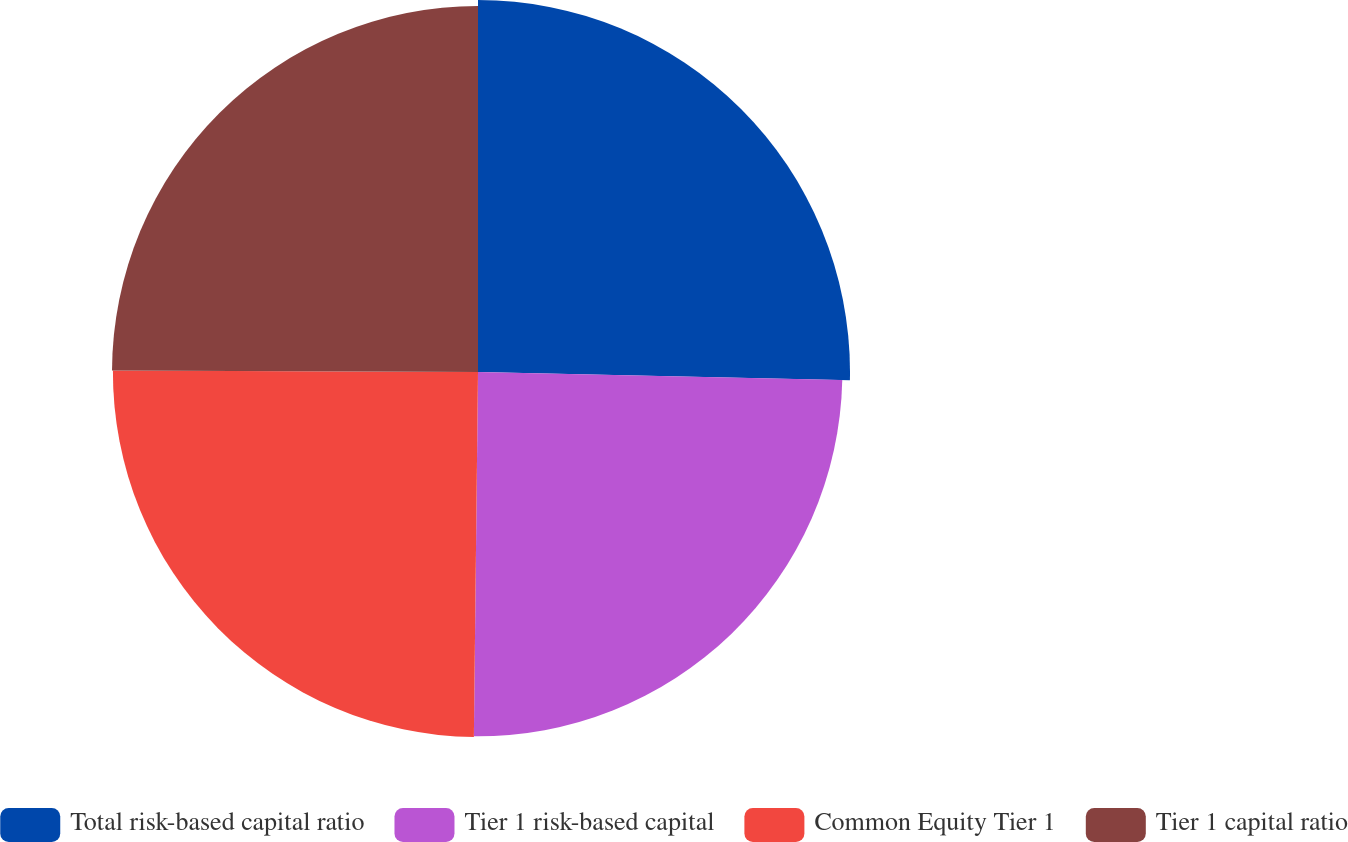Convert chart to OTSL. <chart><loc_0><loc_0><loc_500><loc_500><pie_chart><fcel>Total risk-based capital ratio<fcel>Tier 1 risk-based capital<fcel>Common Equity Tier 1<fcel>Tier 1 capital ratio<nl><fcel>25.35%<fcel>24.83%<fcel>24.88%<fcel>24.94%<nl></chart> 